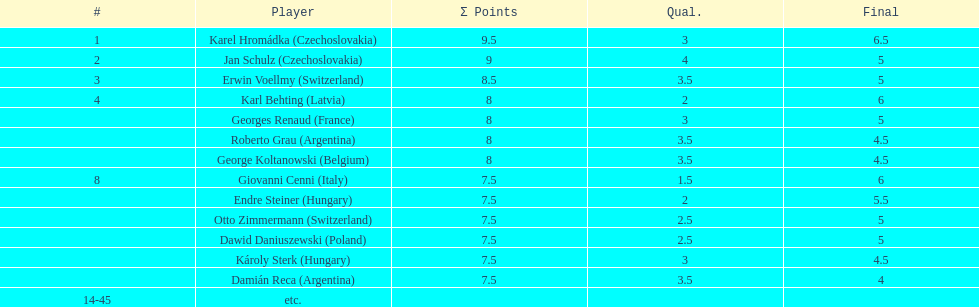Jan schulz is ranked immediately below which player? Karel Hromádka. Would you be able to parse every entry in this table? {'header': ['#', 'Player', 'Σ Points', 'Qual.', 'Final'], 'rows': [['1', 'Karel Hromádka\xa0(Czechoslovakia)', '9.5', '3', '6.5'], ['2', 'Jan Schulz\xa0(Czechoslovakia)', '9', '4', '5'], ['3', 'Erwin Voellmy\xa0(Switzerland)', '8.5', '3.5', '5'], ['4', 'Karl Behting\xa0(Latvia)', '8', '2', '6'], ['', 'Georges Renaud\xa0(France)', '8', '3', '5'], ['', 'Roberto Grau\xa0(Argentina)', '8', '3.5', '4.5'], ['', 'George Koltanowski\xa0(Belgium)', '8', '3.5', '4.5'], ['8', 'Giovanni Cenni\xa0(Italy)', '7.5', '1.5', '6'], ['', 'Endre Steiner\xa0(Hungary)', '7.5', '2', '5.5'], ['', 'Otto Zimmermann\xa0(Switzerland)', '7.5', '2.5', '5'], ['', 'Dawid Daniuszewski\xa0(Poland)', '7.5', '2.5', '5'], ['', 'Károly Sterk\xa0(Hungary)', '7.5', '3', '4.5'], ['', 'Damián Reca\xa0(Argentina)', '7.5', '3.5', '4'], ['14-45', 'etc.', '', '', '']]} 